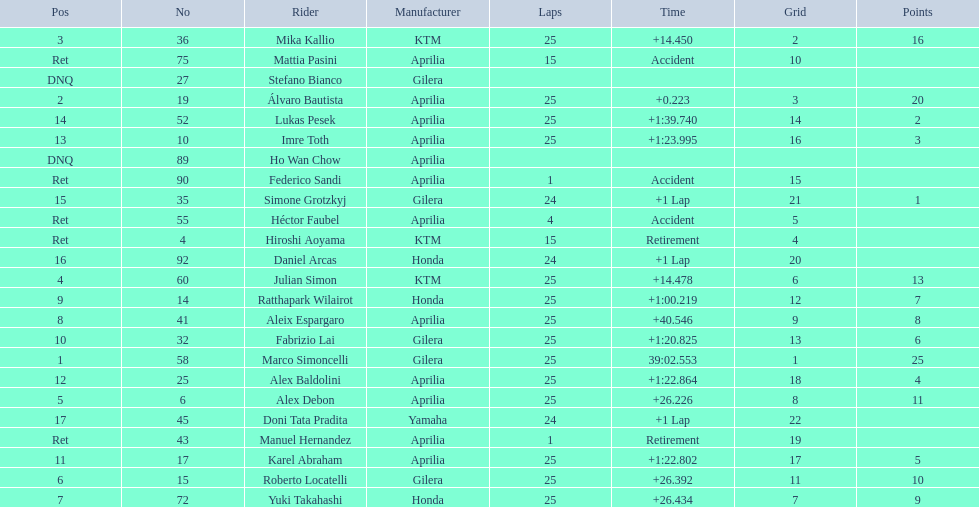How many laps did hiroshi aoyama perform? 15. How many laps did marco simoncelli perform? 25. Who performed more laps out of hiroshi aoyama and marco 
simoncelli? Marco Simoncelli. 